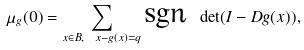<formula> <loc_0><loc_0><loc_500><loc_500>\mu _ { g } ( 0 ) = \sum _ { x \in B , \ x - g ( x ) = q } \text {sgn } \det ( I - D g ( x ) ) ,</formula> 